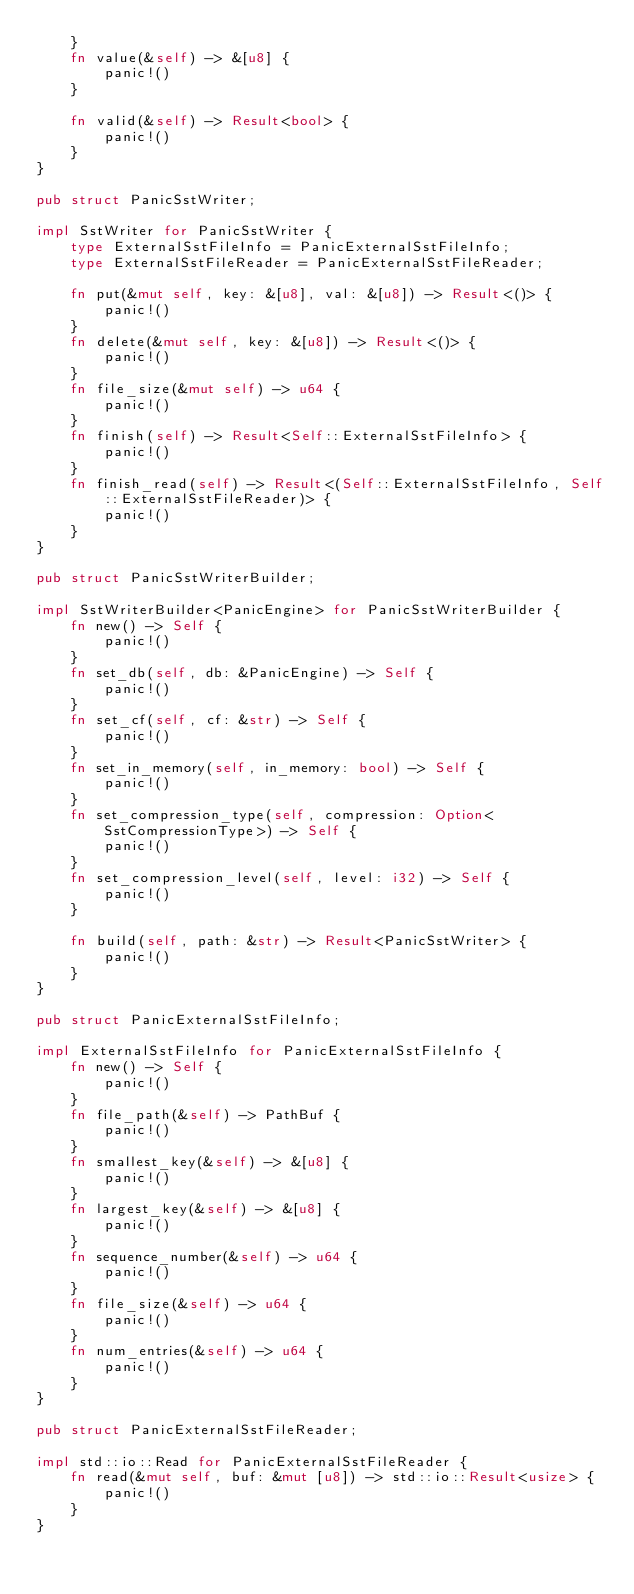Convert code to text. <code><loc_0><loc_0><loc_500><loc_500><_Rust_>    }
    fn value(&self) -> &[u8] {
        panic!()
    }

    fn valid(&self) -> Result<bool> {
        panic!()
    }
}

pub struct PanicSstWriter;

impl SstWriter for PanicSstWriter {
    type ExternalSstFileInfo = PanicExternalSstFileInfo;
    type ExternalSstFileReader = PanicExternalSstFileReader;

    fn put(&mut self, key: &[u8], val: &[u8]) -> Result<()> {
        panic!()
    }
    fn delete(&mut self, key: &[u8]) -> Result<()> {
        panic!()
    }
    fn file_size(&mut self) -> u64 {
        panic!()
    }
    fn finish(self) -> Result<Self::ExternalSstFileInfo> {
        panic!()
    }
    fn finish_read(self) -> Result<(Self::ExternalSstFileInfo, Self::ExternalSstFileReader)> {
        panic!()
    }
}

pub struct PanicSstWriterBuilder;

impl SstWriterBuilder<PanicEngine> for PanicSstWriterBuilder {
    fn new() -> Self {
        panic!()
    }
    fn set_db(self, db: &PanicEngine) -> Self {
        panic!()
    }
    fn set_cf(self, cf: &str) -> Self {
        panic!()
    }
    fn set_in_memory(self, in_memory: bool) -> Self {
        panic!()
    }
    fn set_compression_type(self, compression: Option<SstCompressionType>) -> Self {
        panic!()
    }
    fn set_compression_level(self, level: i32) -> Self {
        panic!()
    }

    fn build(self, path: &str) -> Result<PanicSstWriter> {
        panic!()
    }
}

pub struct PanicExternalSstFileInfo;

impl ExternalSstFileInfo for PanicExternalSstFileInfo {
    fn new() -> Self {
        panic!()
    }
    fn file_path(&self) -> PathBuf {
        panic!()
    }
    fn smallest_key(&self) -> &[u8] {
        panic!()
    }
    fn largest_key(&self) -> &[u8] {
        panic!()
    }
    fn sequence_number(&self) -> u64 {
        panic!()
    }
    fn file_size(&self) -> u64 {
        panic!()
    }
    fn num_entries(&self) -> u64 {
        panic!()
    }
}

pub struct PanicExternalSstFileReader;

impl std::io::Read for PanicExternalSstFileReader {
    fn read(&mut self, buf: &mut [u8]) -> std::io::Result<usize> {
        panic!()
    }
}
</code> 